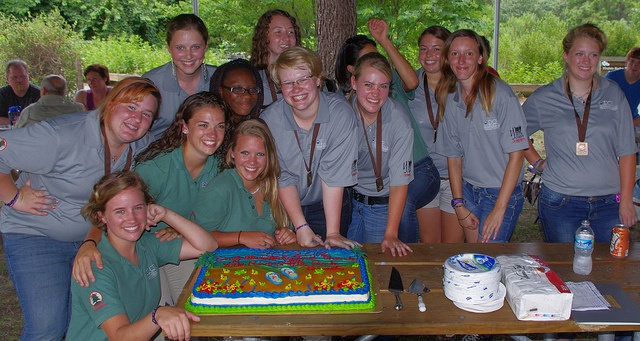Describe the objects in this image and their specific colors. I can see dining table in darkgreen, maroon, lightgray, and gray tones, people in darkgreen, gray, darkblue, and brown tones, people in darkgreen, gray, black, maroon, and brown tones, people in darkgreen, gray, navy, and brown tones, and people in darkgreen, gray, brown, and maroon tones in this image. 